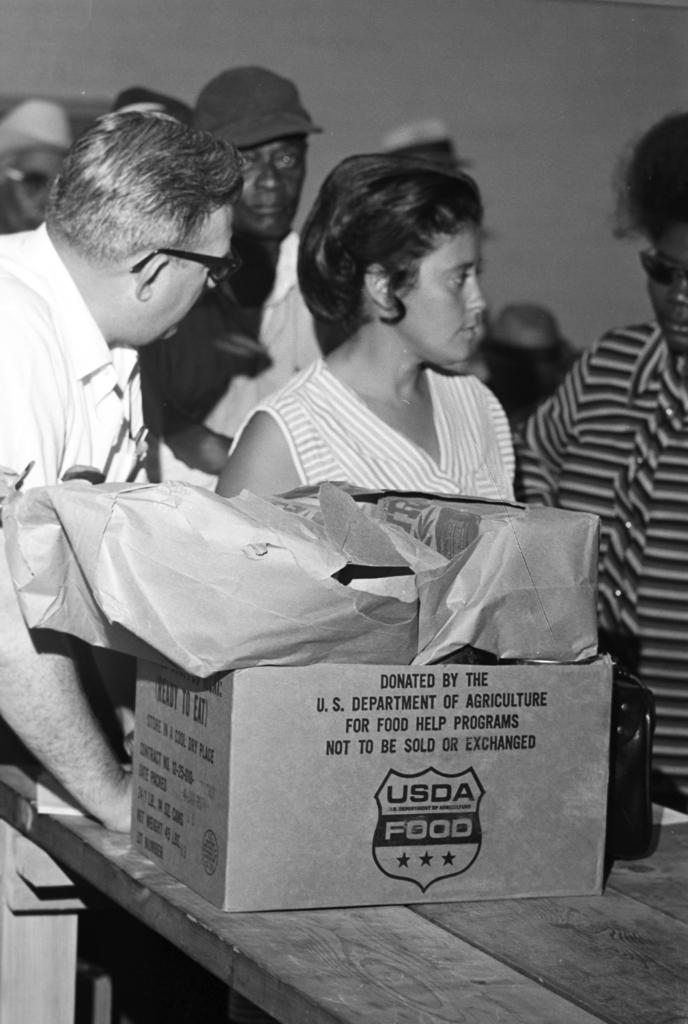What is the color scheme of the image? The image is black and white. What can be seen in the image besides the people and table? Cardboard boxes are placed on the table. Can you see any bones on the table in the image? There are no bones visible in the image; it features people standing beside a table with cardboard boxes. Is there a hill in the background of the image? There is no hill present in the image; it is a black and white image of people standing beside a table with cardboard boxes. 